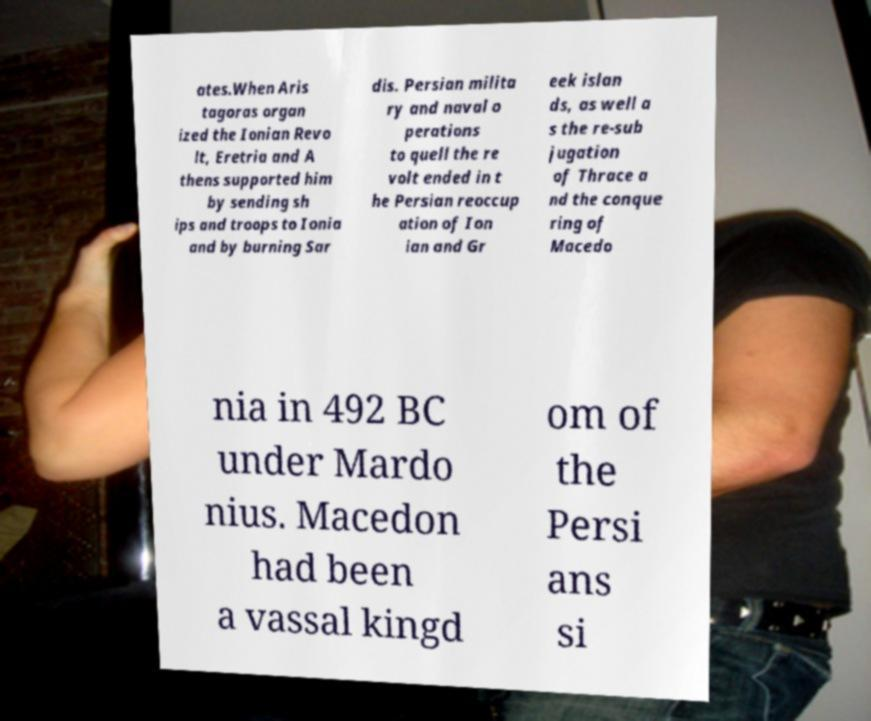Could you extract and type out the text from this image? ates.When Aris tagoras organ ized the Ionian Revo lt, Eretria and A thens supported him by sending sh ips and troops to Ionia and by burning Sar dis. Persian milita ry and naval o perations to quell the re volt ended in t he Persian reoccup ation of Ion ian and Gr eek islan ds, as well a s the re-sub jugation of Thrace a nd the conque ring of Macedo nia in 492 BC under Mardo nius. Macedon had been a vassal kingd om of the Persi ans si 